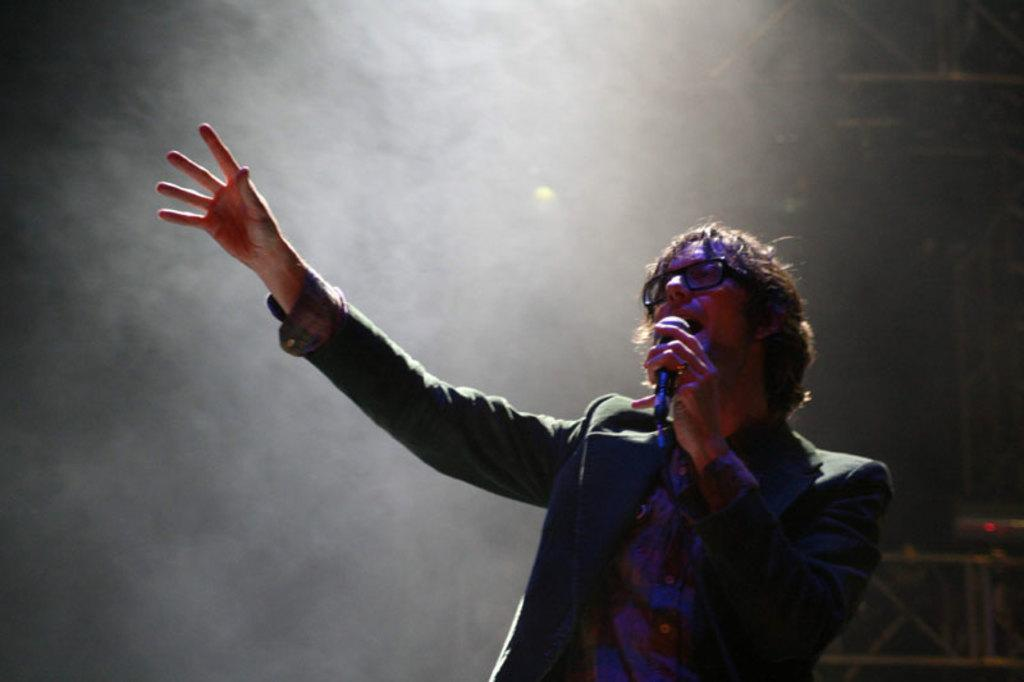What is the person in the image doing? The person is singing. What object is the person holding while singing? The person is holding a microphone. What can be seen in the background of the image? There is a fence in the background of the image. What is the source of illumination in the image? There is a light in the image. What type of riddle is the person trying to solve in the image? There is no riddle present in the image; the person is singing and holding a microphone. 